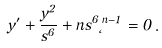Convert formula to latex. <formula><loc_0><loc_0><loc_500><loc_500>y ^ { \prime } + \frac { y ^ { 2 } } { s ^ { 6 } } + n s ^ { 6 } \Phi ^ { n - 1 } = 0 \, .</formula> 